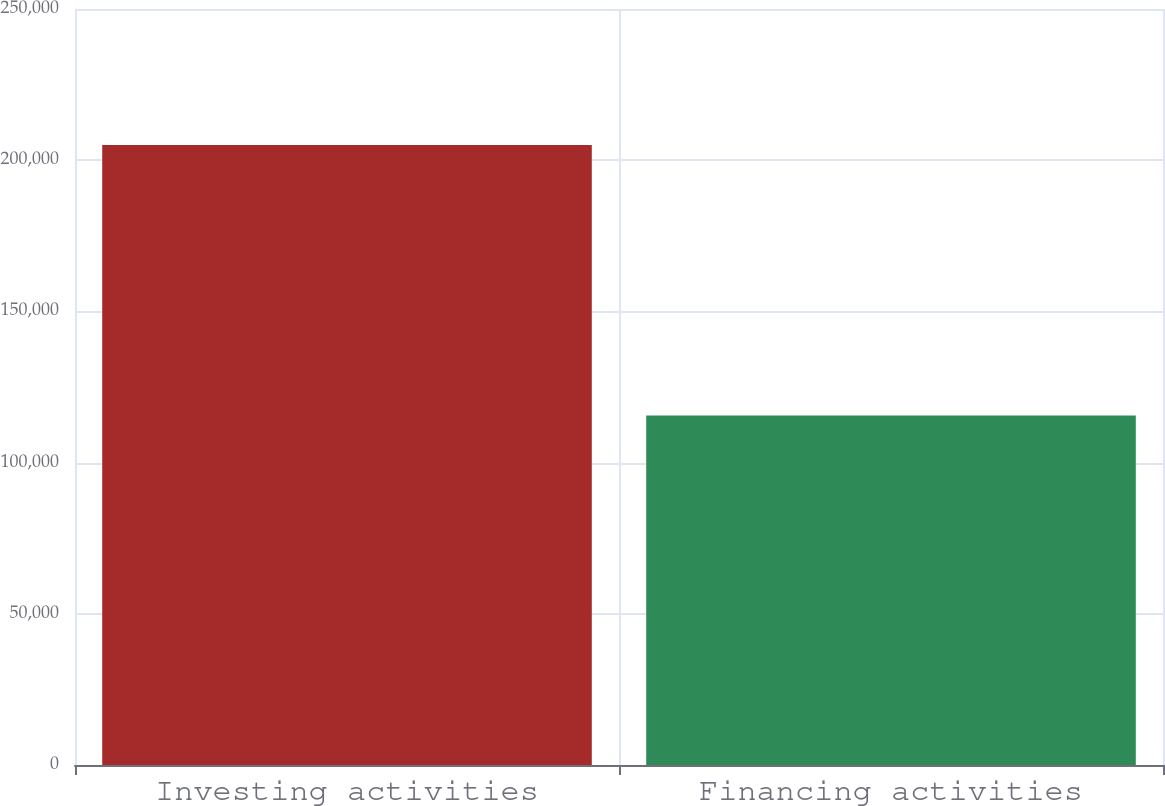Convert chart to OTSL. <chart><loc_0><loc_0><loc_500><loc_500><bar_chart><fcel>Investing activities<fcel>Financing activities<nl><fcel>205051<fcel>115542<nl></chart> 